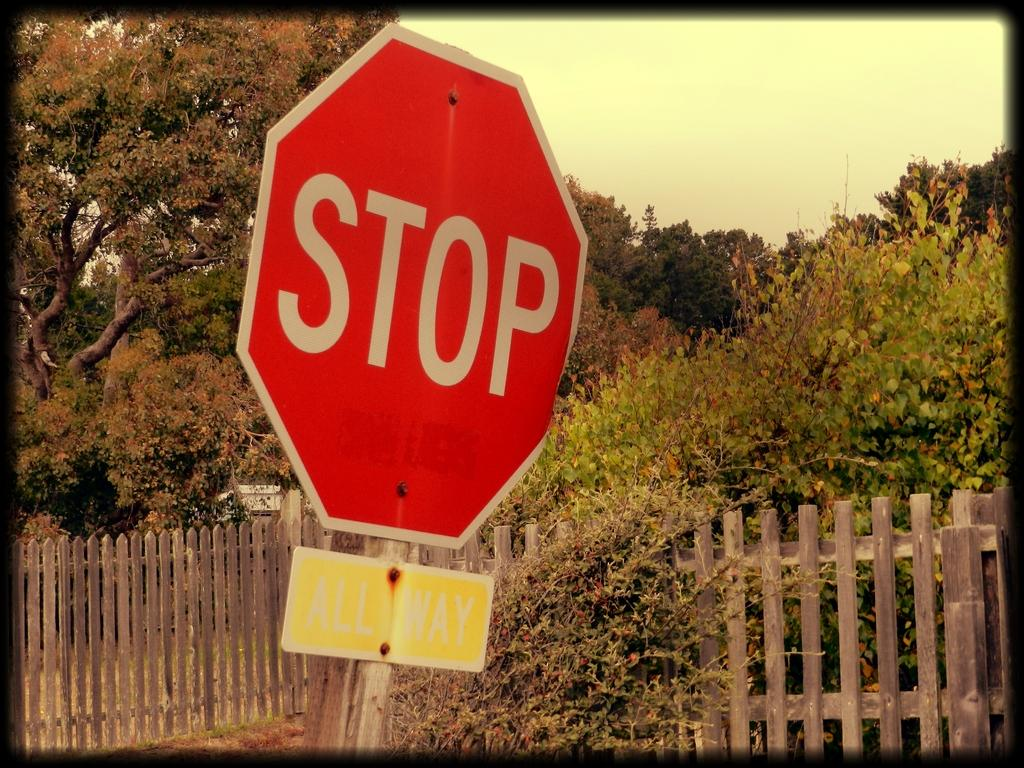<image>
Present a compact description of the photo's key features. A red STOP sign has a yellow ALL WAY sign below it. 